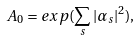Convert formula to latex. <formula><loc_0><loc_0><loc_500><loc_500>A _ { 0 } = e x p ( \sum _ { s } | \alpha _ { s } | ^ { 2 } ) ,</formula> 